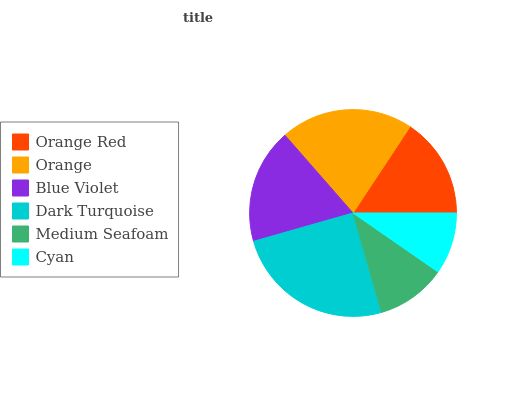Is Cyan the minimum?
Answer yes or no. Yes. Is Dark Turquoise the maximum?
Answer yes or no. Yes. Is Orange the minimum?
Answer yes or no. No. Is Orange the maximum?
Answer yes or no. No. Is Orange greater than Orange Red?
Answer yes or no. Yes. Is Orange Red less than Orange?
Answer yes or no. Yes. Is Orange Red greater than Orange?
Answer yes or no. No. Is Orange less than Orange Red?
Answer yes or no. No. Is Blue Violet the high median?
Answer yes or no. Yes. Is Orange Red the low median?
Answer yes or no. Yes. Is Orange Red the high median?
Answer yes or no. No. Is Orange the low median?
Answer yes or no. No. 